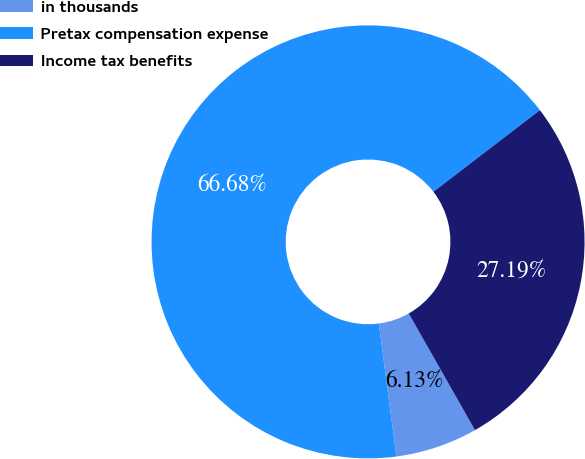Convert chart to OTSL. <chart><loc_0><loc_0><loc_500><loc_500><pie_chart><fcel>in thousands<fcel>Pretax compensation expense<fcel>Income tax benefits<nl><fcel>6.13%<fcel>66.68%<fcel>27.19%<nl></chart> 